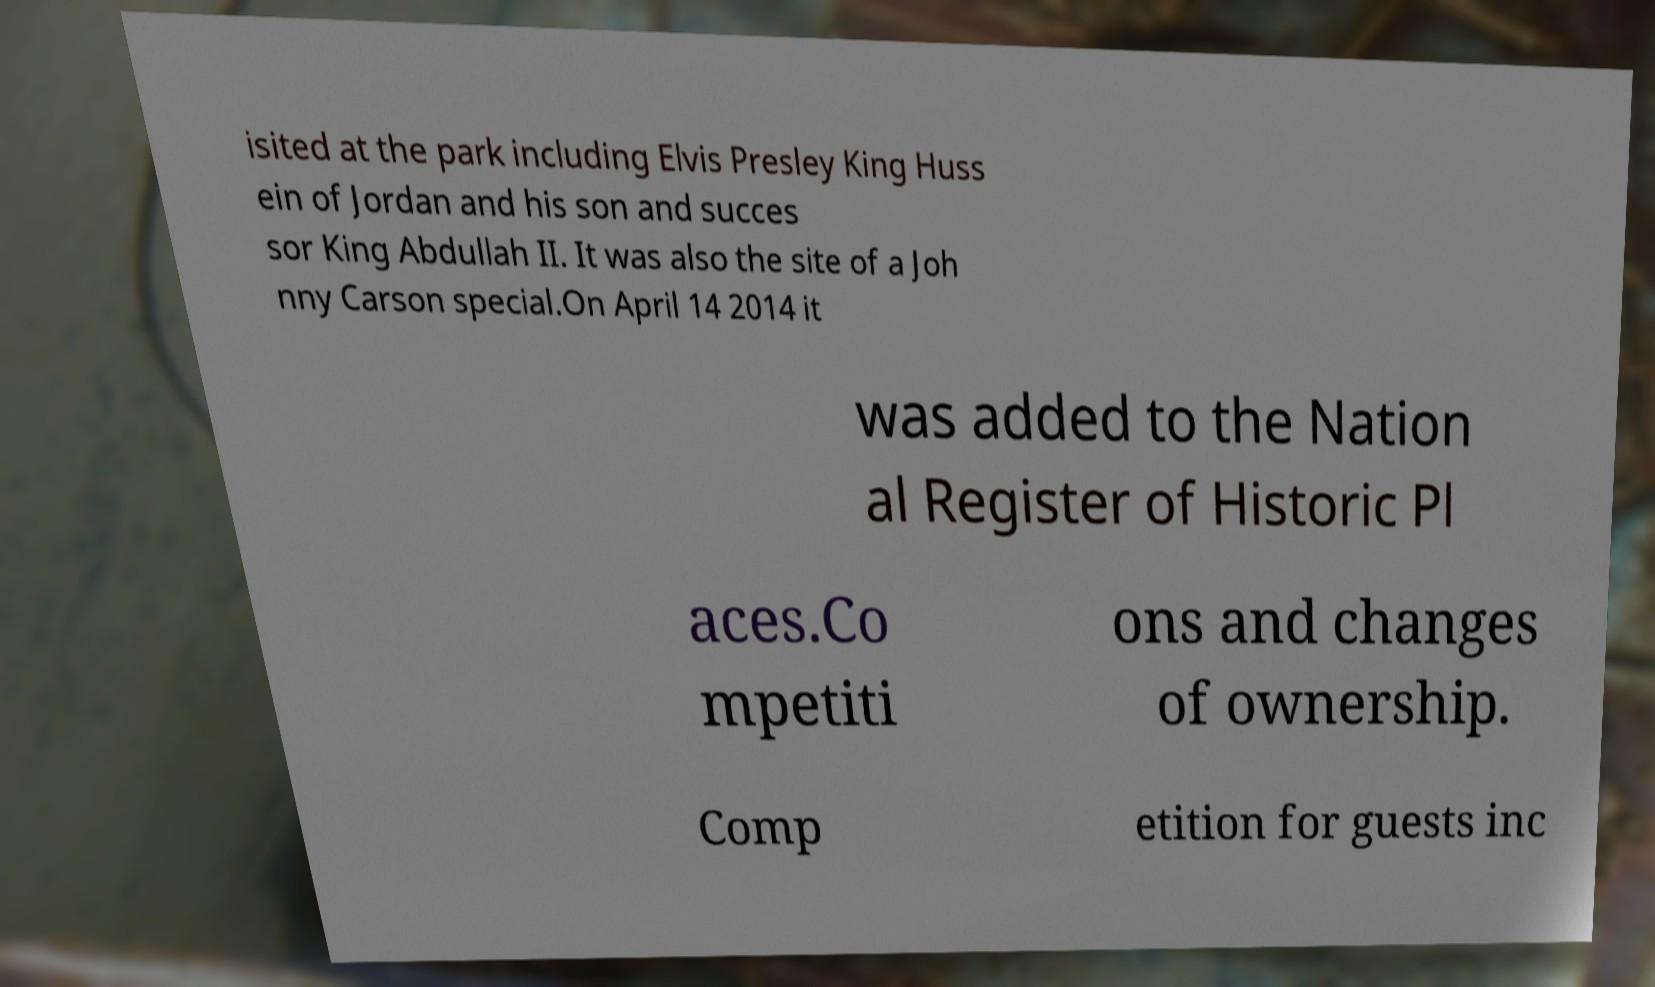Can you read and provide the text displayed in the image?This photo seems to have some interesting text. Can you extract and type it out for me? isited at the park including Elvis Presley King Huss ein of Jordan and his son and succes sor King Abdullah II. It was also the site of a Joh nny Carson special.On April 14 2014 it was added to the Nation al Register of Historic Pl aces.Co mpetiti ons and changes of ownership. Comp etition for guests inc 